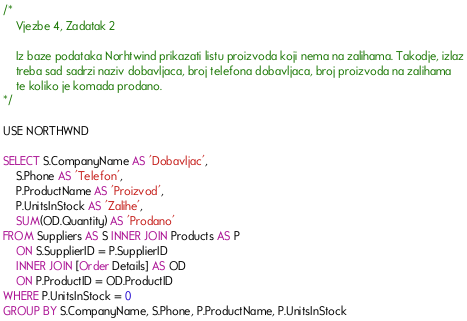<code> <loc_0><loc_0><loc_500><loc_500><_SQL_>/*
	Vjezbe 4, Zadatak 2
	
	Iz baze podataka Norhtwind prikazati listu proizvoda koji nema na zalihama. Takodje, izlaz
	treba sad sadrzi naziv dobavljaca, broj telefona dobavljaca, broj proizvoda na zalihama
	te koliko je komada prodano.
*/

USE NORTHWND

SELECT S.CompanyName AS 'Dobavljac',
	S.Phone AS 'Telefon',
	P.ProductName AS 'Proizvod',
	P.UnitsInStock AS 'Zalihe',
	SUM(OD.Quantity) AS 'Prodano'
FROM Suppliers AS S INNER JOIN Products AS P
	ON S.SupplierID = P.SupplierID
	INNER JOIN [Order Details] AS OD
	ON P.ProductID = OD.ProductID
WHERE P.UnitsInStock = 0
GROUP BY S.CompanyName, S.Phone, P.ProductName, P.UnitsInStock</code> 